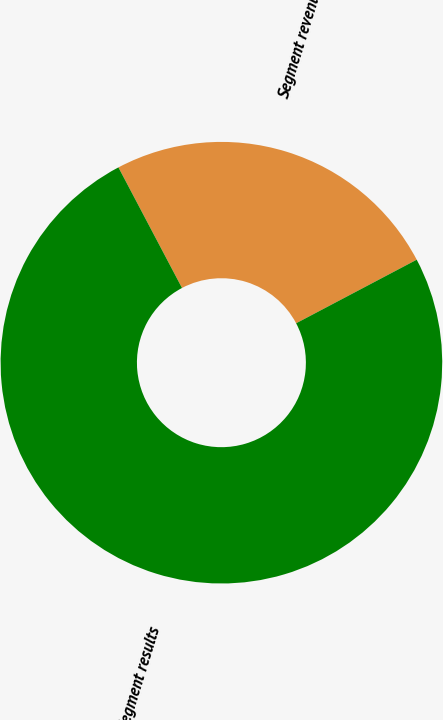Convert chart to OTSL. <chart><loc_0><loc_0><loc_500><loc_500><pie_chart><fcel>Segment revenues<fcel>Segment results<nl><fcel>25.0%<fcel>75.0%<nl></chart> 